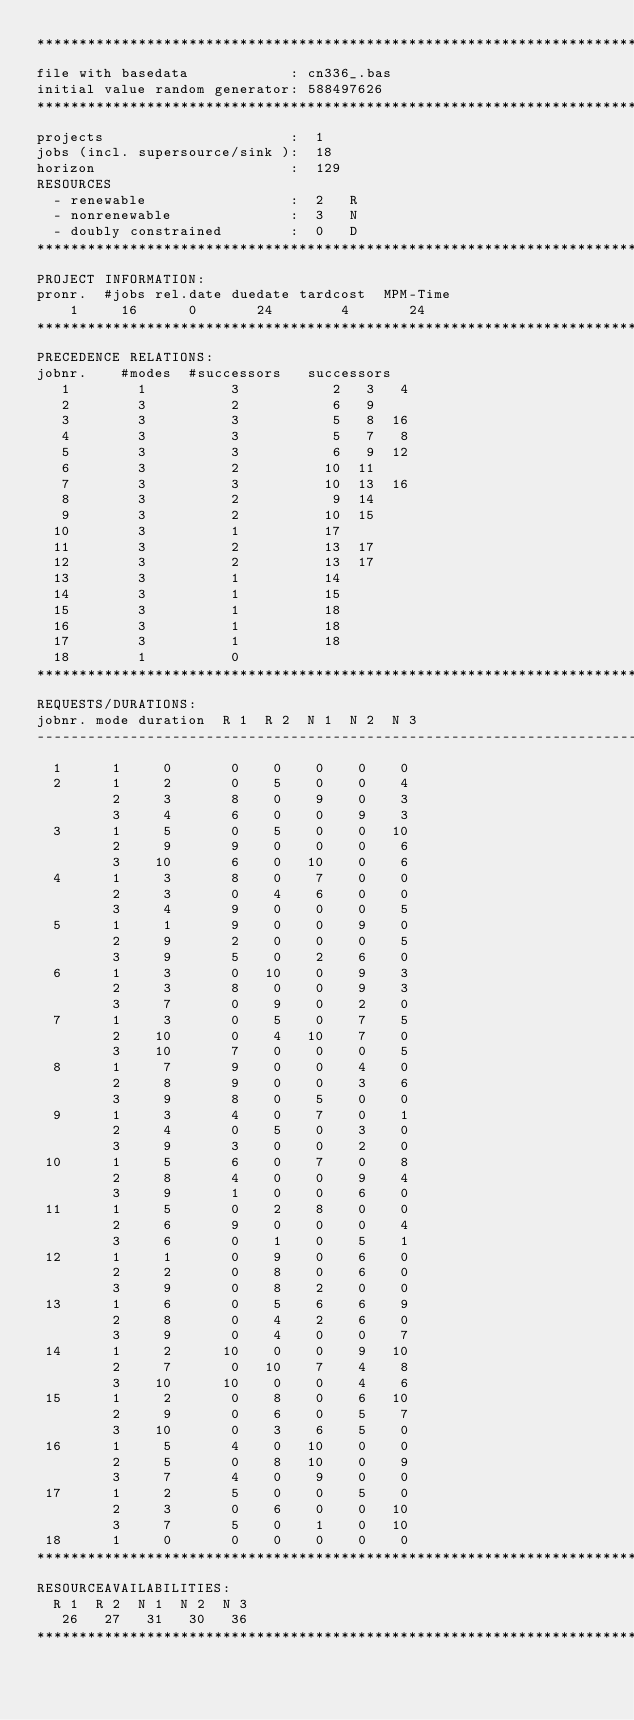<code> <loc_0><loc_0><loc_500><loc_500><_ObjectiveC_>************************************************************************
file with basedata            : cn336_.bas
initial value random generator: 588497626
************************************************************************
projects                      :  1
jobs (incl. supersource/sink ):  18
horizon                       :  129
RESOURCES
  - renewable                 :  2   R
  - nonrenewable              :  3   N
  - doubly constrained        :  0   D
************************************************************************
PROJECT INFORMATION:
pronr.  #jobs rel.date duedate tardcost  MPM-Time
    1     16      0       24        4       24
************************************************************************
PRECEDENCE RELATIONS:
jobnr.    #modes  #successors   successors
   1        1          3           2   3   4
   2        3          2           6   9
   3        3          3           5   8  16
   4        3          3           5   7   8
   5        3          3           6   9  12
   6        3          2          10  11
   7        3          3          10  13  16
   8        3          2           9  14
   9        3          2          10  15
  10        3          1          17
  11        3          2          13  17
  12        3          2          13  17
  13        3          1          14
  14        3          1          15
  15        3          1          18
  16        3          1          18
  17        3          1          18
  18        1          0        
************************************************************************
REQUESTS/DURATIONS:
jobnr. mode duration  R 1  R 2  N 1  N 2  N 3
------------------------------------------------------------------------
  1      1     0       0    0    0    0    0
  2      1     2       0    5    0    0    4
         2     3       8    0    9    0    3
         3     4       6    0    0    9    3
  3      1     5       0    5    0    0   10
         2     9       9    0    0    0    6
         3    10       6    0   10    0    6
  4      1     3       8    0    7    0    0
         2     3       0    4    6    0    0
         3     4       9    0    0    0    5
  5      1     1       9    0    0    9    0
         2     9       2    0    0    0    5
         3     9       5    0    2    6    0
  6      1     3       0   10    0    9    3
         2     3       8    0    0    9    3
         3     7       0    9    0    2    0
  7      1     3       0    5    0    7    5
         2    10       0    4   10    7    0
         3    10       7    0    0    0    5
  8      1     7       9    0    0    4    0
         2     8       9    0    0    3    6
         3     9       8    0    5    0    0
  9      1     3       4    0    7    0    1
         2     4       0    5    0    3    0
         3     9       3    0    0    2    0
 10      1     5       6    0    7    0    8
         2     8       4    0    0    9    4
         3     9       1    0    0    6    0
 11      1     5       0    2    8    0    0
         2     6       9    0    0    0    4
         3     6       0    1    0    5    1
 12      1     1       0    9    0    6    0
         2     2       0    8    0    6    0
         3     9       0    8    2    0    0
 13      1     6       0    5    6    6    9
         2     8       0    4    2    6    0
         3     9       0    4    0    0    7
 14      1     2      10    0    0    9   10
         2     7       0   10    7    4    8
         3    10      10    0    0    4    6
 15      1     2       0    8    0    6   10
         2     9       0    6    0    5    7
         3    10       0    3    6    5    0
 16      1     5       4    0   10    0    0
         2     5       0    8   10    0    9
         3     7       4    0    9    0    0
 17      1     2       5    0    0    5    0
         2     3       0    6    0    0   10
         3     7       5    0    1    0   10
 18      1     0       0    0    0    0    0
************************************************************************
RESOURCEAVAILABILITIES:
  R 1  R 2  N 1  N 2  N 3
   26   27   31   30   36
************************************************************************
</code> 